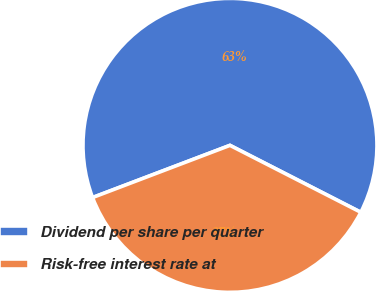Convert chart. <chart><loc_0><loc_0><loc_500><loc_500><pie_chart><fcel>Dividend per share per quarter<fcel>Risk-free interest rate at<nl><fcel>63.3%<fcel>36.7%<nl></chart> 